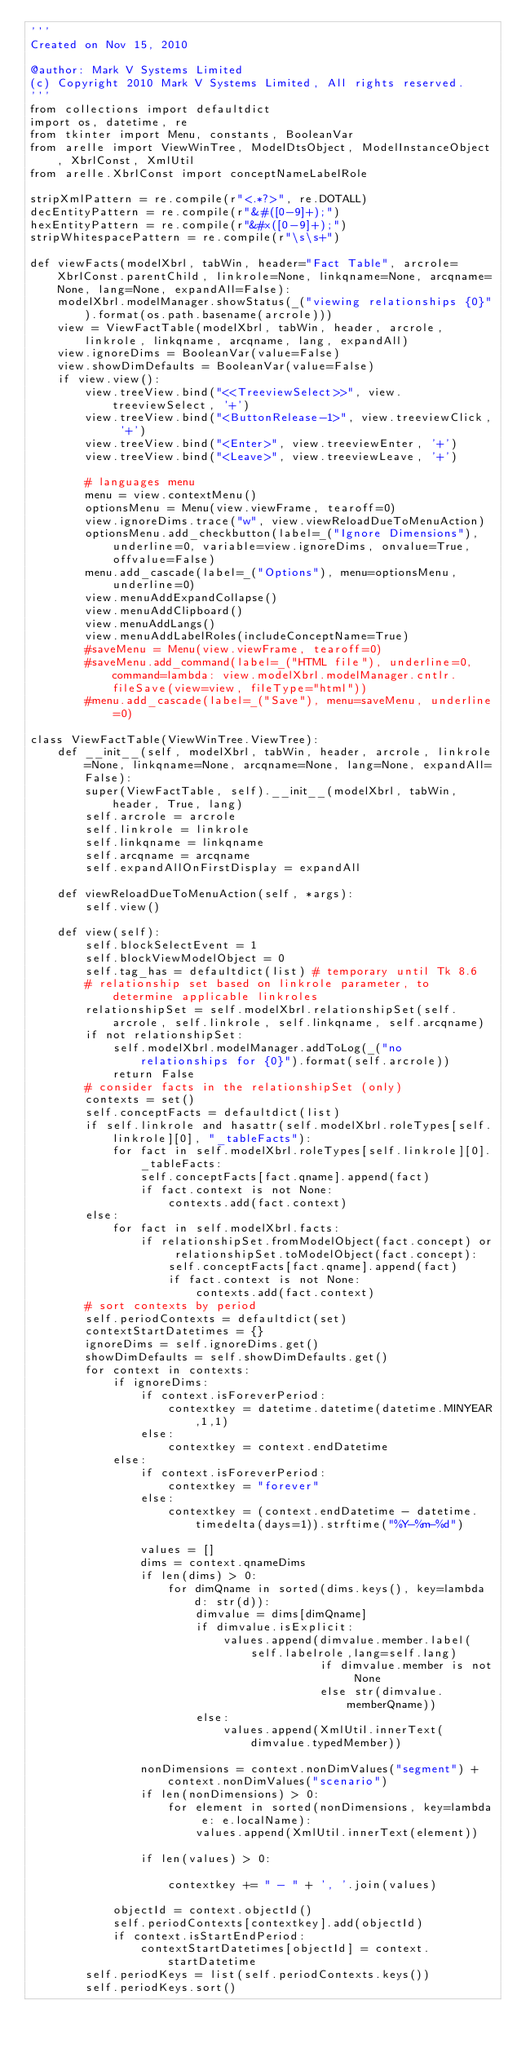Convert code to text. <code><loc_0><loc_0><loc_500><loc_500><_Python_>'''
Created on Nov 15, 2010

@author: Mark V Systems Limited
(c) Copyright 2010 Mark V Systems Limited, All rights reserved.
'''
from collections import defaultdict
import os, datetime, re
from tkinter import Menu, constants, BooleanVar
from arelle import ViewWinTree, ModelDtsObject, ModelInstanceObject, XbrlConst, XmlUtil
from arelle.XbrlConst import conceptNameLabelRole

stripXmlPattern = re.compile(r"<.*?>", re.DOTALL)
decEntityPattern = re.compile(r"&#([0-9]+);")
hexEntityPattern = re.compile(r"&#x([0-9]+);")
stripWhitespacePattern = re.compile(r"\s\s+")

def viewFacts(modelXbrl, tabWin, header="Fact Table", arcrole=XbrlConst.parentChild, linkrole=None, linkqname=None, arcqname=None, lang=None, expandAll=False):
    modelXbrl.modelManager.showStatus(_("viewing relationships {0}").format(os.path.basename(arcrole)))
    view = ViewFactTable(modelXbrl, tabWin, header, arcrole, linkrole, linkqname, arcqname, lang, expandAll)
    view.ignoreDims = BooleanVar(value=False)
    view.showDimDefaults = BooleanVar(value=False)
    if view.view():
        view.treeView.bind("<<TreeviewSelect>>", view.treeviewSelect, '+')
        view.treeView.bind("<ButtonRelease-1>", view.treeviewClick, '+')
        view.treeView.bind("<Enter>", view.treeviewEnter, '+')
        view.treeView.bind("<Leave>", view.treeviewLeave, '+')

        # languages menu
        menu = view.contextMenu()
        optionsMenu = Menu(view.viewFrame, tearoff=0)
        view.ignoreDims.trace("w", view.viewReloadDueToMenuAction)
        optionsMenu.add_checkbutton(label=_("Ignore Dimensions"), underline=0, variable=view.ignoreDims, onvalue=True, offvalue=False)
        menu.add_cascade(label=_("Options"), menu=optionsMenu, underline=0)
        view.menuAddExpandCollapse()
        view.menuAddClipboard()
        view.menuAddLangs()
        view.menuAddLabelRoles(includeConceptName=True)
        #saveMenu = Menu(view.viewFrame, tearoff=0)
        #saveMenu.add_command(label=_("HTML file"), underline=0, command=lambda: view.modelXbrl.modelManager.cntlr.fileSave(view=view, fileType="html"))
        #menu.add_cascade(label=_("Save"), menu=saveMenu, underline=0)
    
class ViewFactTable(ViewWinTree.ViewTree):
    def __init__(self, modelXbrl, tabWin, header, arcrole, linkrole=None, linkqname=None, arcqname=None, lang=None, expandAll=False):
        super(ViewFactTable, self).__init__(modelXbrl, tabWin, header, True, lang)
        self.arcrole = arcrole
        self.linkrole = linkrole
        self.linkqname = linkqname
        self.arcqname = arcqname
        self.expandAllOnFirstDisplay = expandAll
        
    def viewReloadDueToMenuAction(self, *args):
        self.view()
        
    def view(self):
        self.blockSelectEvent = 1
        self.blockViewModelObject = 0
        self.tag_has = defaultdict(list) # temporary until Tk 8.6
        # relationship set based on linkrole parameter, to determine applicable linkroles
        relationshipSet = self.modelXbrl.relationshipSet(self.arcrole, self.linkrole, self.linkqname, self.arcqname)
        if not relationshipSet:
            self.modelXbrl.modelManager.addToLog(_("no relationships for {0}").format(self.arcrole))
            return False
        # consider facts in the relationshipSet (only)
        contexts = set()
        self.conceptFacts = defaultdict(list)
        if self.linkrole and hasattr(self.modelXbrl.roleTypes[self.linkrole][0], "_tableFacts"):
            for fact in self.modelXbrl.roleTypes[self.linkrole][0]._tableFacts:
                self.conceptFacts[fact.qname].append(fact)
                if fact.context is not None:
                    contexts.add(fact.context)
        else:
            for fact in self.modelXbrl.facts:
                if relationshipSet.fromModelObject(fact.concept) or relationshipSet.toModelObject(fact.concept):
                    self.conceptFacts[fact.qname].append(fact)
                    if fact.context is not None:
                        contexts.add(fact.context)
        # sort contexts by period
        self.periodContexts = defaultdict(set)
        contextStartDatetimes = {}
        ignoreDims = self.ignoreDims.get()
        showDimDefaults = self.showDimDefaults.get()
        for context in contexts:
            if ignoreDims:
                if context.isForeverPeriod:
                    contextkey = datetime.datetime(datetime.MINYEAR,1,1)
                else:
                    contextkey = context.endDatetime
            else:
                if context.isForeverPeriod:
                    contextkey = "forever"
                else:
                    contextkey = (context.endDatetime - datetime.timedelta(days=1)).strftime("%Y-%m-%d")
                
                values = []
                dims = context.qnameDims
                if len(dims) > 0:
                    for dimQname in sorted(dims.keys(), key=lambda d: str(d)):
                        dimvalue = dims[dimQname]
                        if dimvalue.isExplicit:
                            values.append(dimvalue.member.label(self.labelrole,lang=self.lang)
                                          if dimvalue.member is not None 
                                          else str(dimvalue.memberQname))
                        else:
                            values.append(XmlUtil.innerText(dimvalue.typedMember))
                            
                nonDimensions = context.nonDimValues("segment") + context.nonDimValues("scenario")
                if len(nonDimensions) > 0:
                    for element in sorted(nonDimensions, key=lambda e: e.localName):
                        values.append(XmlUtil.innerText(element))

                if len(values) > 0:
    
                    contextkey += " - " + ', '.join(values)

            objectId = context.objectId()
            self.periodContexts[contextkey].add(objectId)
            if context.isStartEndPeriod:
                contextStartDatetimes[objectId] = context.startDatetime
        self.periodKeys = list(self.periodContexts.keys())
        self.periodKeys.sort()</code> 